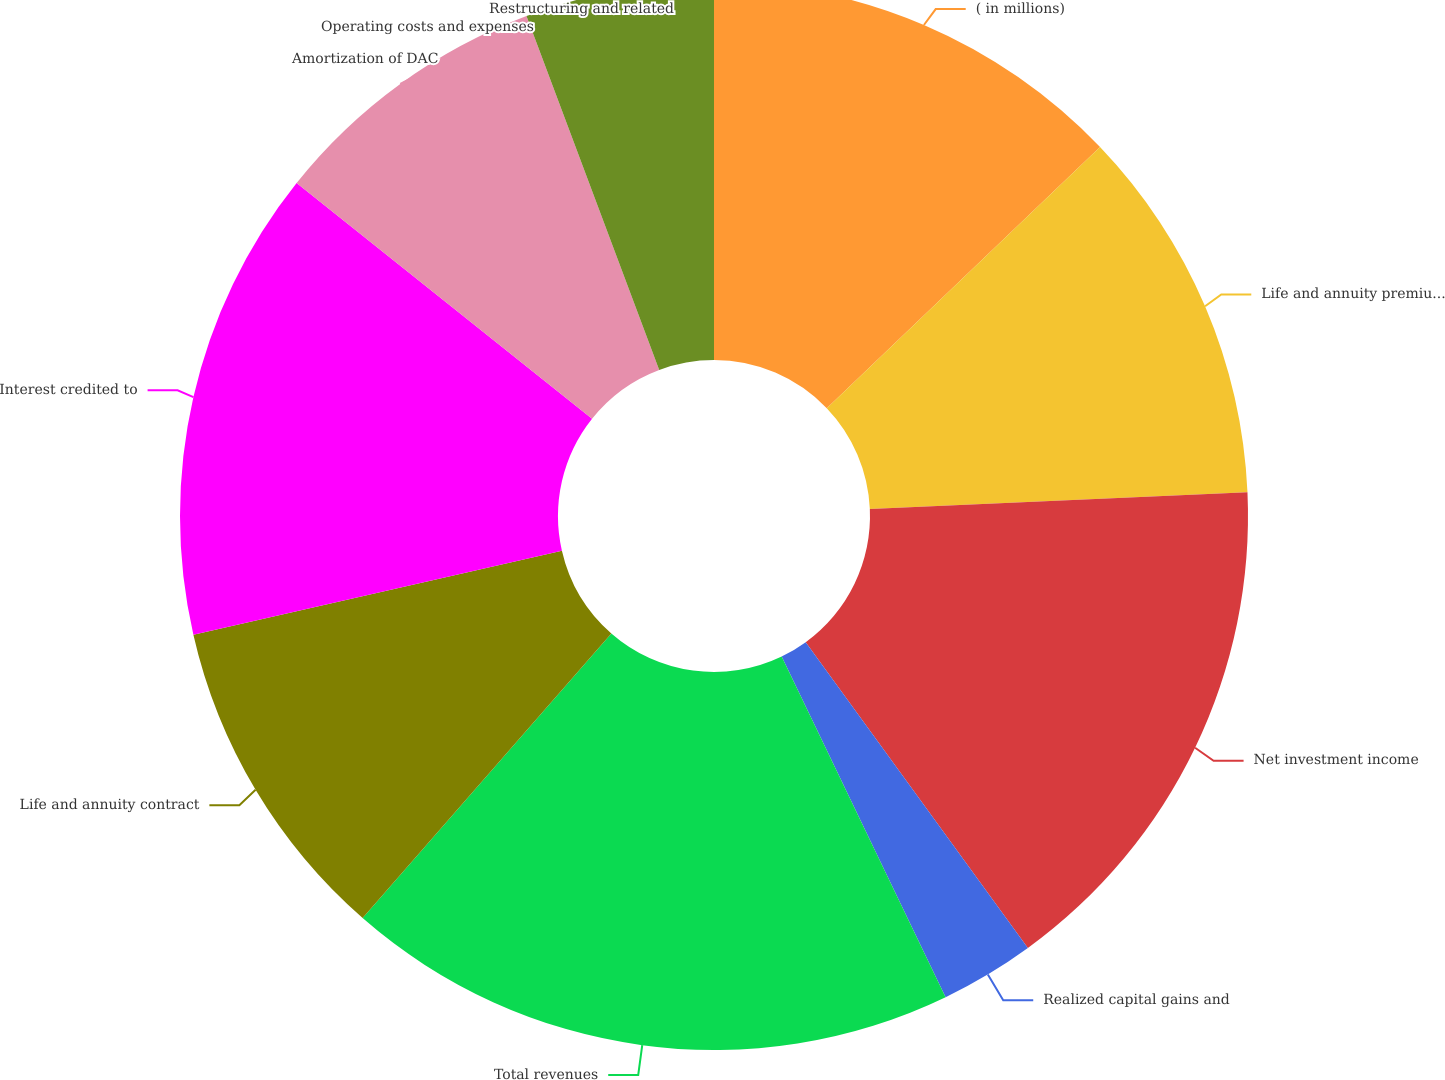Convert chart to OTSL. <chart><loc_0><loc_0><loc_500><loc_500><pie_chart><fcel>( in millions)<fcel>Life and annuity premiums and<fcel>Net investment income<fcel>Realized capital gains and<fcel>Total revenues<fcel>Life and annuity contract<fcel>Interest credited to<fcel>Amortization of DAC<fcel>Operating costs and expenses<fcel>Restructuring and related<nl><fcel>12.86%<fcel>11.43%<fcel>15.71%<fcel>2.86%<fcel>18.57%<fcel>10.0%<fcel>14.29%<fcel>8.57%<fcel>5.71%<fcel>0.0%<nl></chart> 